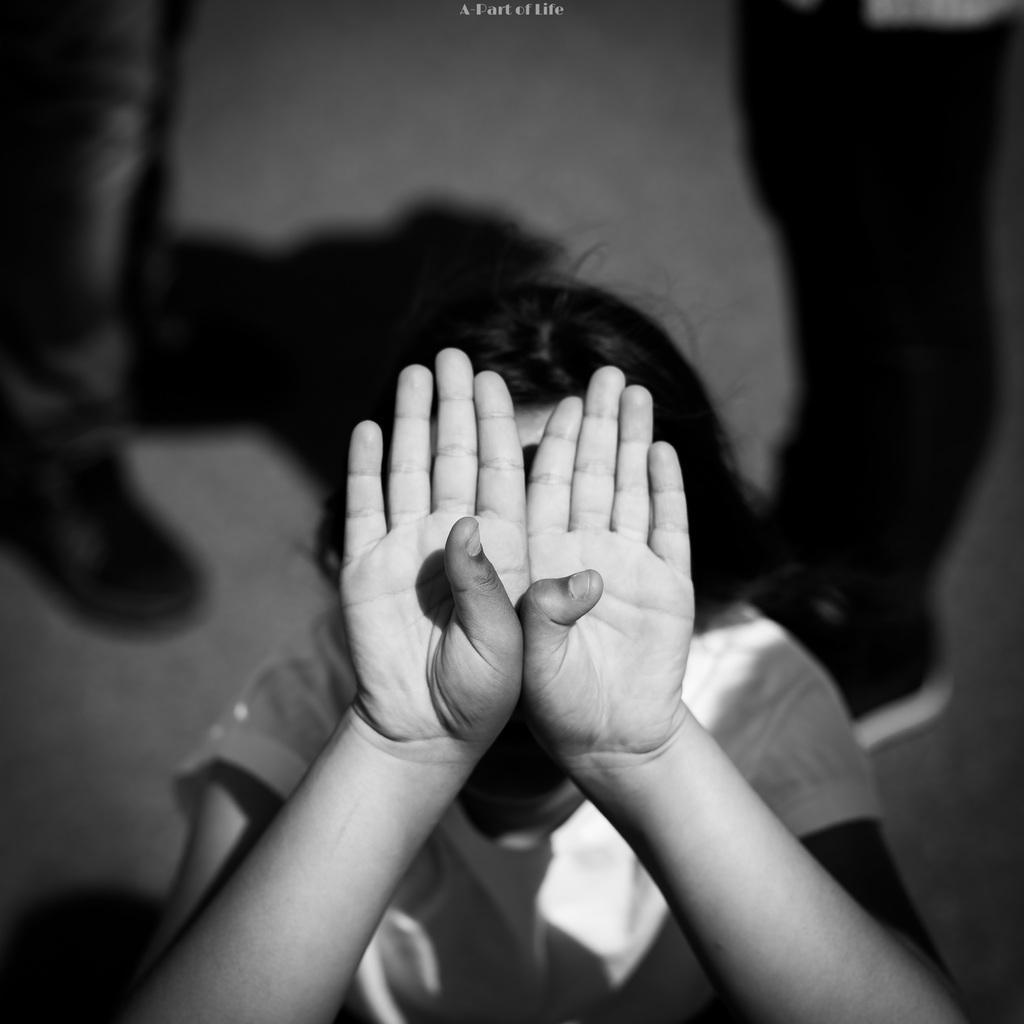Please provide a concise description of this image. This image is a black and white image. In the background two persons are standing on the floor. In the middle of the image there is a kid covering face with hands. 